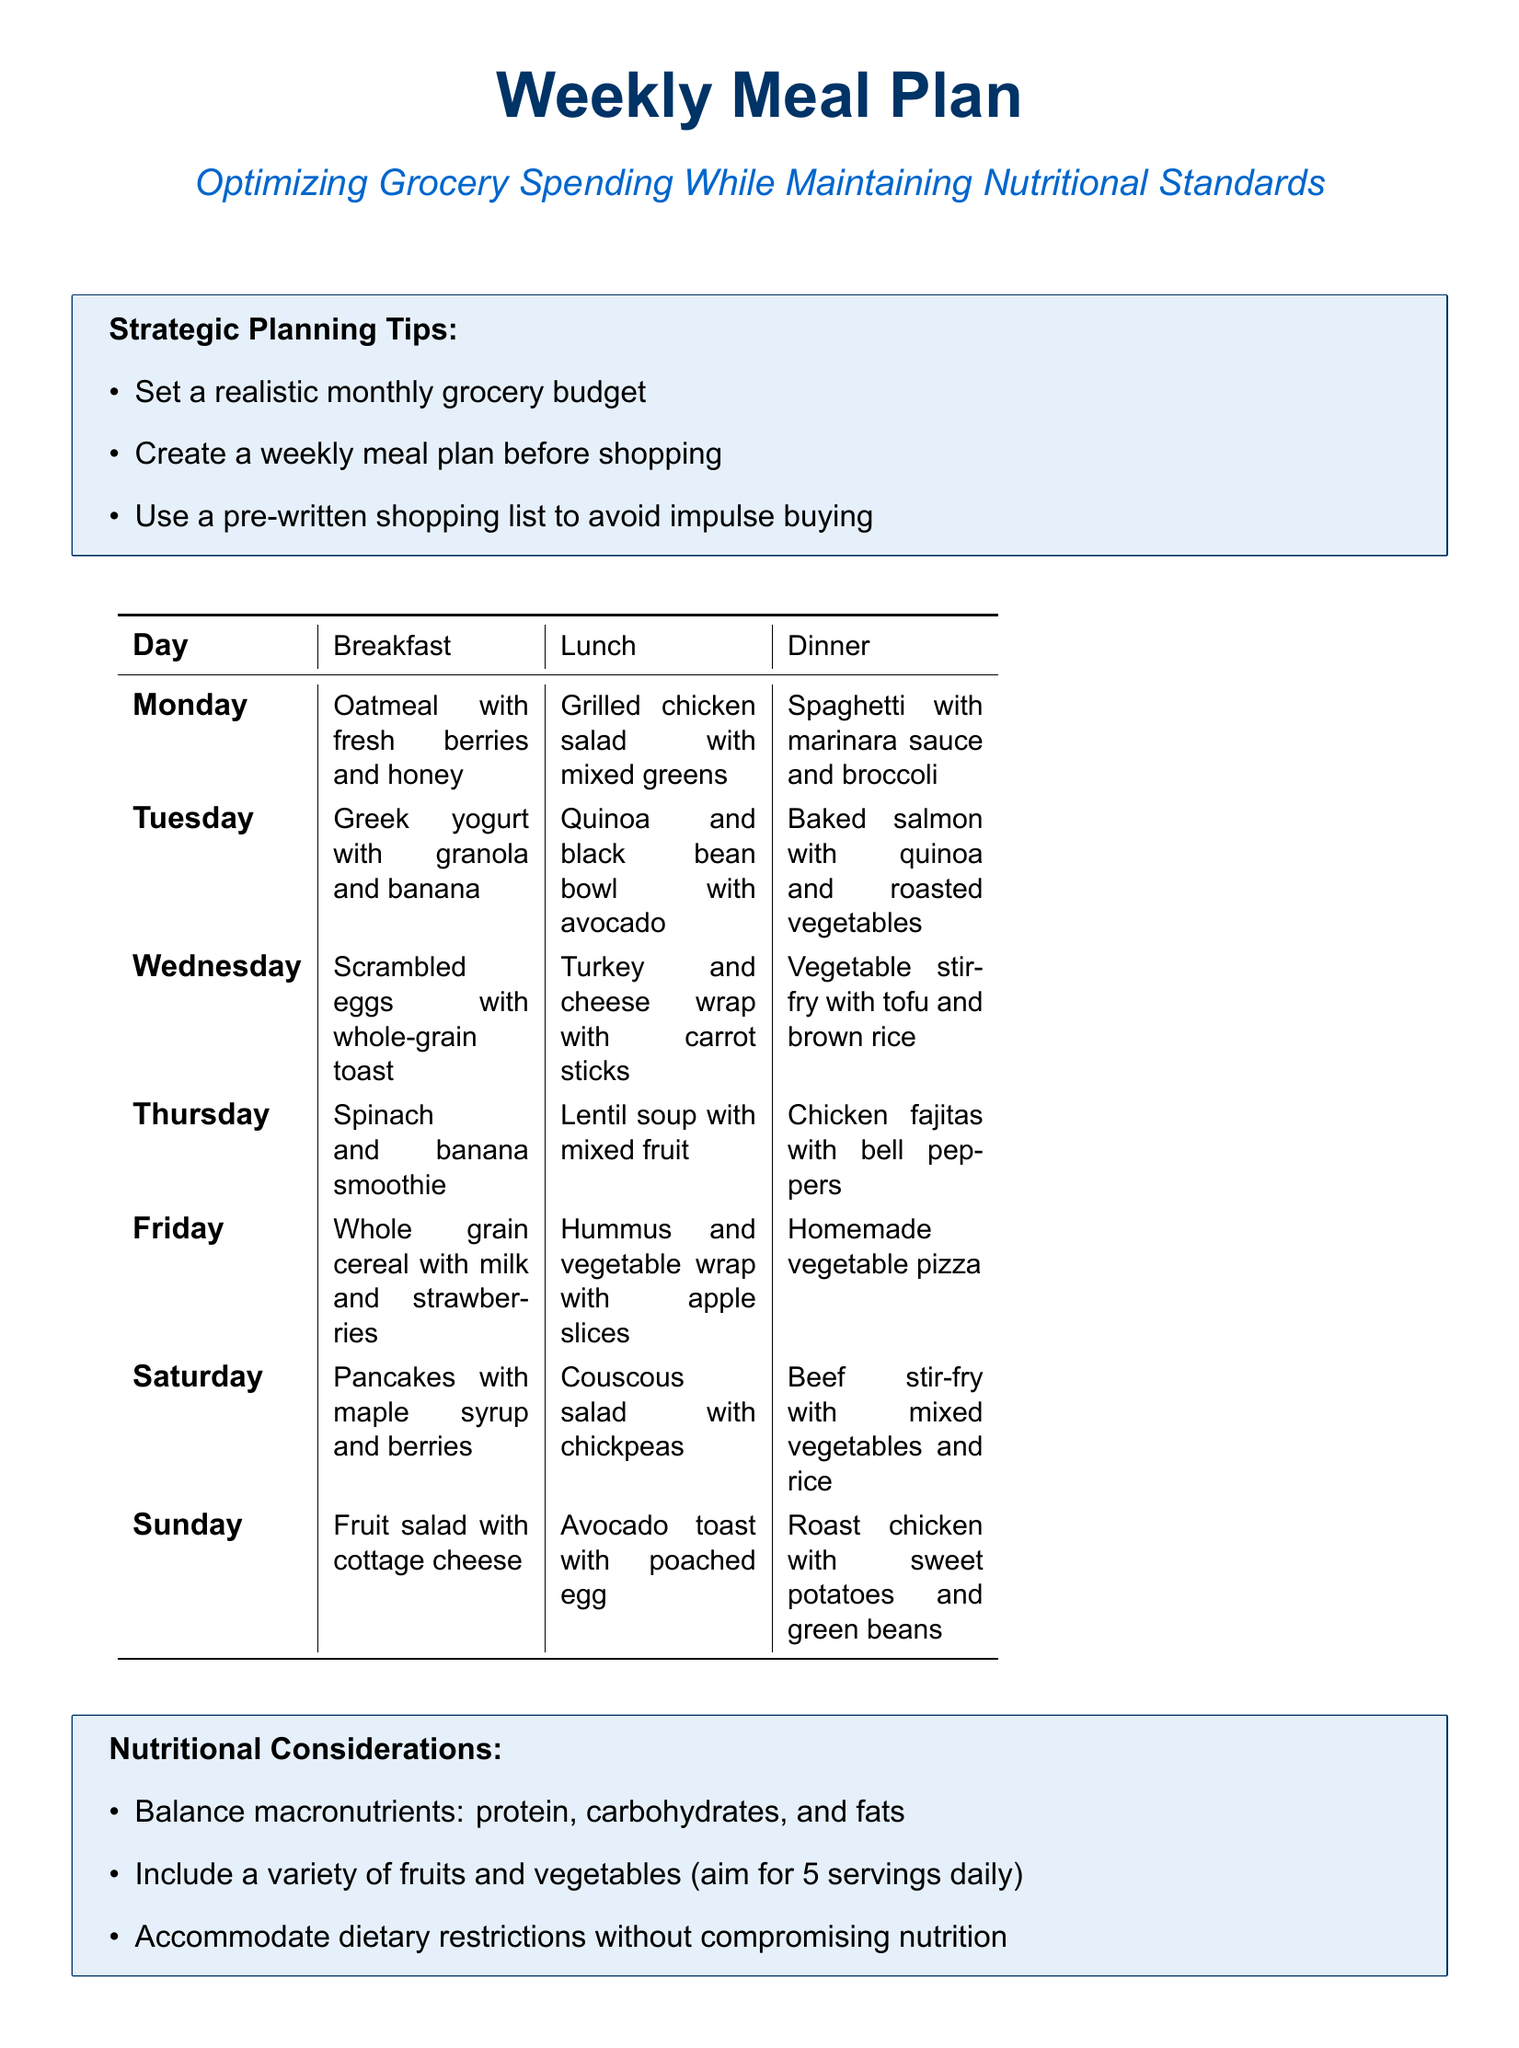what is the main goal of the meal plan? The meal plan aims to optimize grocery spending while maintaining nutritional standards.
Answer: optimizing grocery spending while maintaining nutritional standards how many meals are listed for each day? Each day has three meals listed: breakfast, lunch, and dinner.
Answer: three which day features a spinach and banana smoothie for breakfast? The breakfast listing for Thursday includes a spinach and banana smoothie.
Answer: Thursday what type of soup is included in the Wednesday lunch? The lunch for Wednesday features a turkey and cheese wrap with carrot sticks, while soup is incorrectly mentioned; lentil soup is for Thursday.
Answer: turkey and cheese wrap with carrot sticks how many servings of fruits and vegetables should be included daily? The nutritional considerations state that one should aim for five servings of fruits and vegetables daily.
Answer: five servings what type of yogurt is included in the Tuesday breakfast? The Tuesday breakfast consists of Greek yogurt with granola and banana.
Answer: Greek yogurt what is recommended to avoid due to the pre-written shopping list? The pre-written shopping list helps avoid impulse buying during groceries.
Answer: impulse buying what is one of the strategic planning tips mentioned? One strategic planning tip is to set a realistic monthly grocery budget.
Answer: set a realistic monthly grocery budget which dinner includes roasted vegetables? The dinner on Tuesday features baked salmon with quinoa and roasted vegetables.
Answer: baked salmon with quinoa and roasted vegetables 